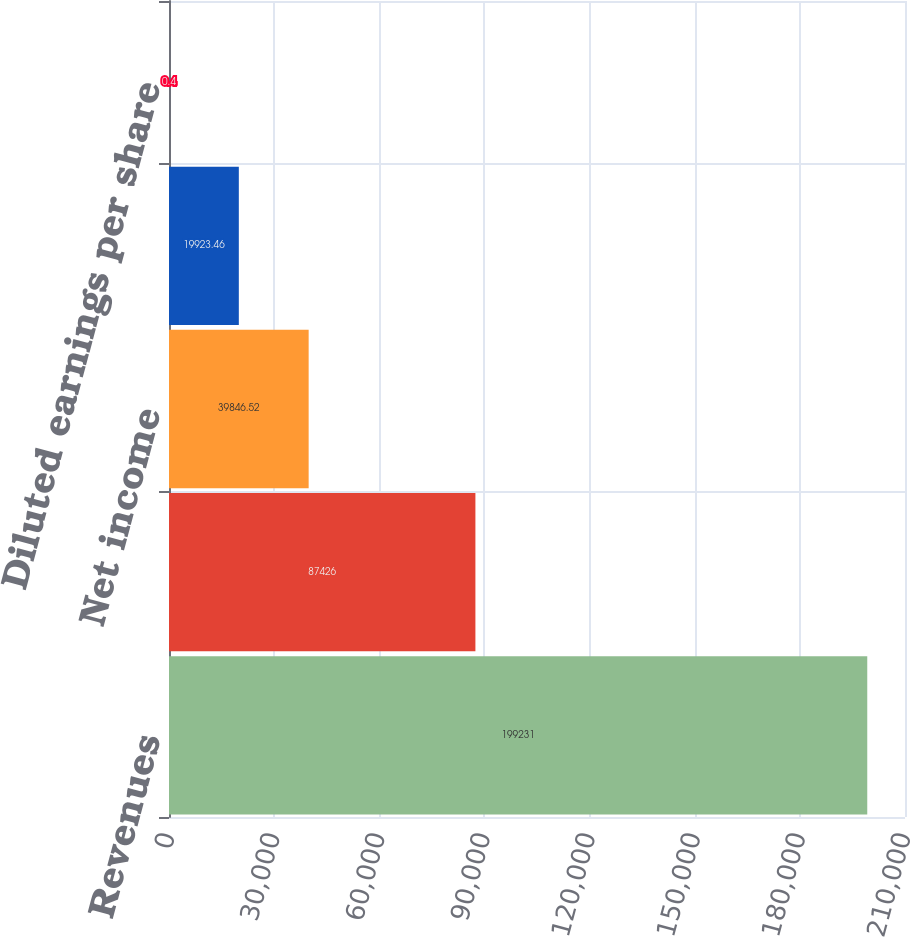Convert chart to OTSL. <chart><loc_0><loc_0><loc_500><loc_500><bar_chart><fcel>Revenues<fcel>Gross profit<fcel>Net income<fcel>Basic earnings per share<fcel>Diluted earnings per share<nl><fcel>199231<fcel>87426<fcel>39846.5<fcel>19923.5<fcel>0.4<nl></chart> 